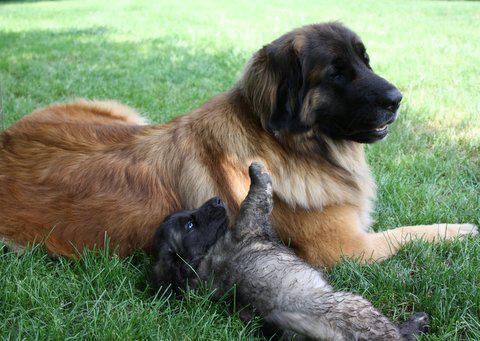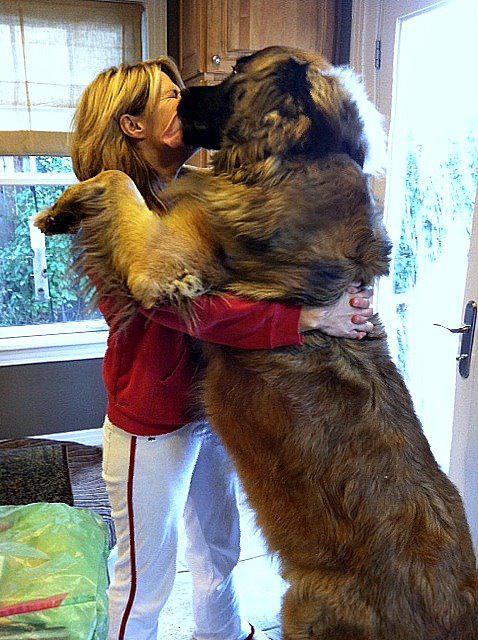The first image is the image on the left, the second image is the image on the right. Evaluate the accuracy of this statement regarding the images: "There's at least one human petting a dog.". Is it true? Answer yes or no. Yes. The first image is the image on the left, the second image is the image on the right. Evaluate the accuracy of this statement regarding the images: "There are three dogs in one of the images.". Is it true? Answer yes or no. No. 